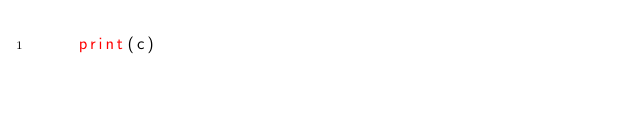<code> <loc_0><loc_0><loc_500><loc_500><_Python_>    print(c)</code> 